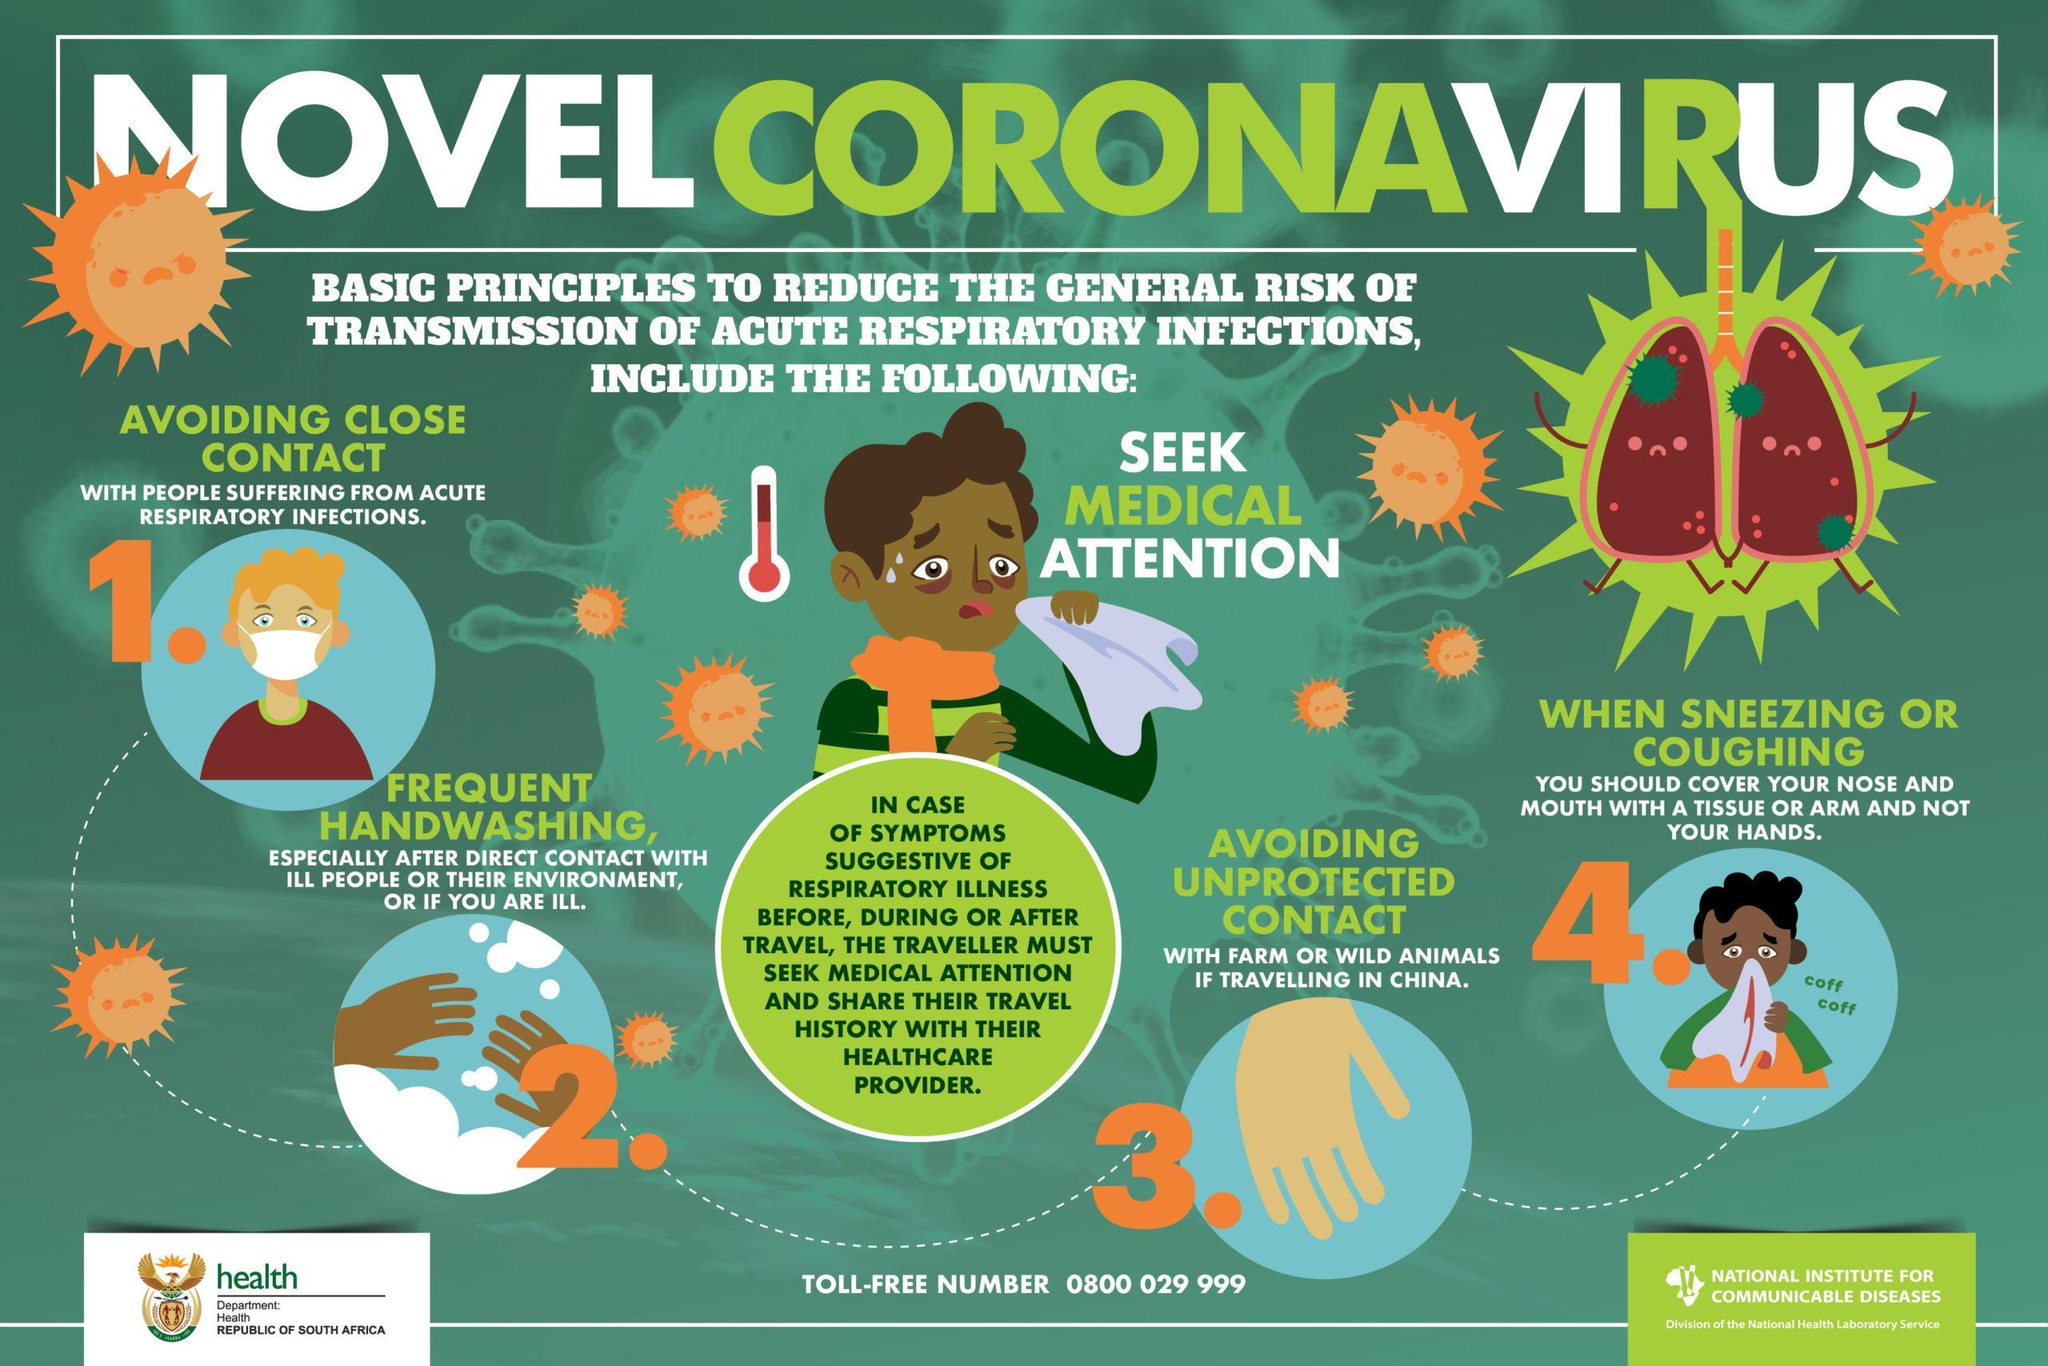What two measures should a traveller having symptoms of respiratory illnesses take?
Answer the question with a short phrase. Seek medical attention and share their travel history with their healthcare provider When should you cover your nose and mouth with the tissue? When sneezing or coughing What is the general principle to be followed after direct contact with ill people or their environment? Frequent handwashing What is the general principle to be followed while you are with farm or wild animals? Avoiding unprotected contact What is the first principle to reduce the general risk of transmission? Avoiding close contact with people suffering from acute respiratory infections How many principles are mentioned here? 4 